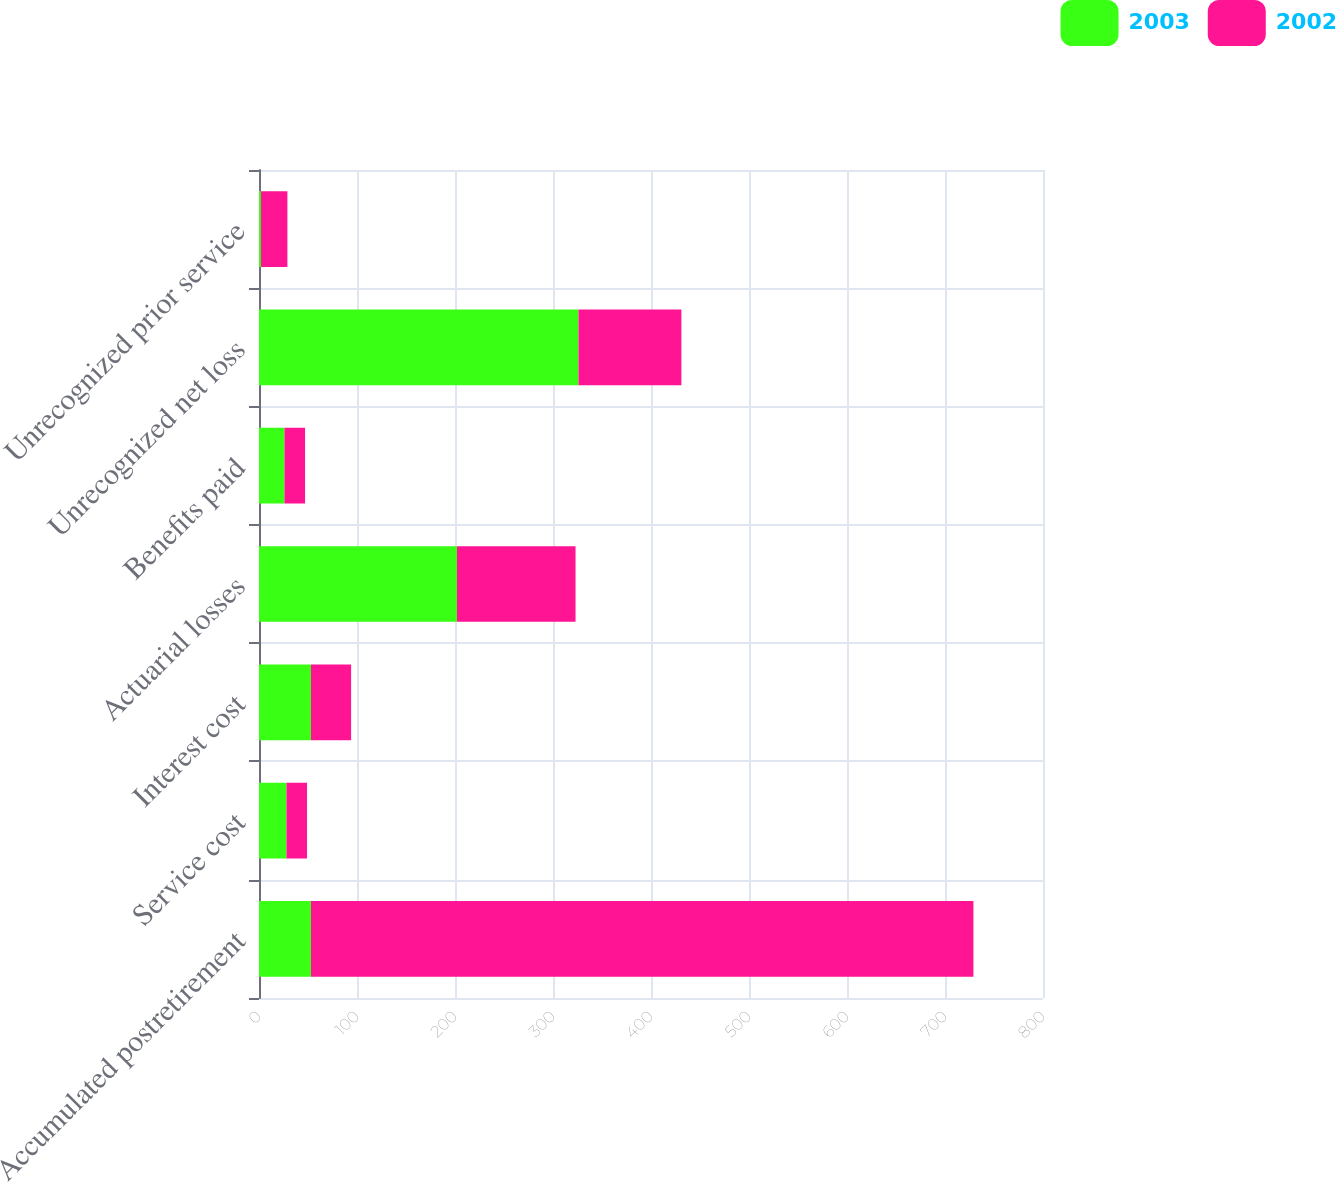Convert chart to OTSL. <chart><loc_0><loc_0><loc_500><loc_500><stacked_bar_chart><ecel><fcel>Accumulated postretirement<fcel>Service cost<fcel>Interest cost<fcel>Actuarial losses<fcel>Benefits paid<fcel>Unrecognized net loss<fcel>Unrecognized prior service<nl><fcel>2003<fcel>53<fcel>28<fcel>53<fcel>202<fcel>26<fcel>326<fcel>2<nl><fcel>2002<fcel>676<fcel>21<fcel>41<fcel>121<fcel>21<fcel>105<fcel>27<nl></chart> 